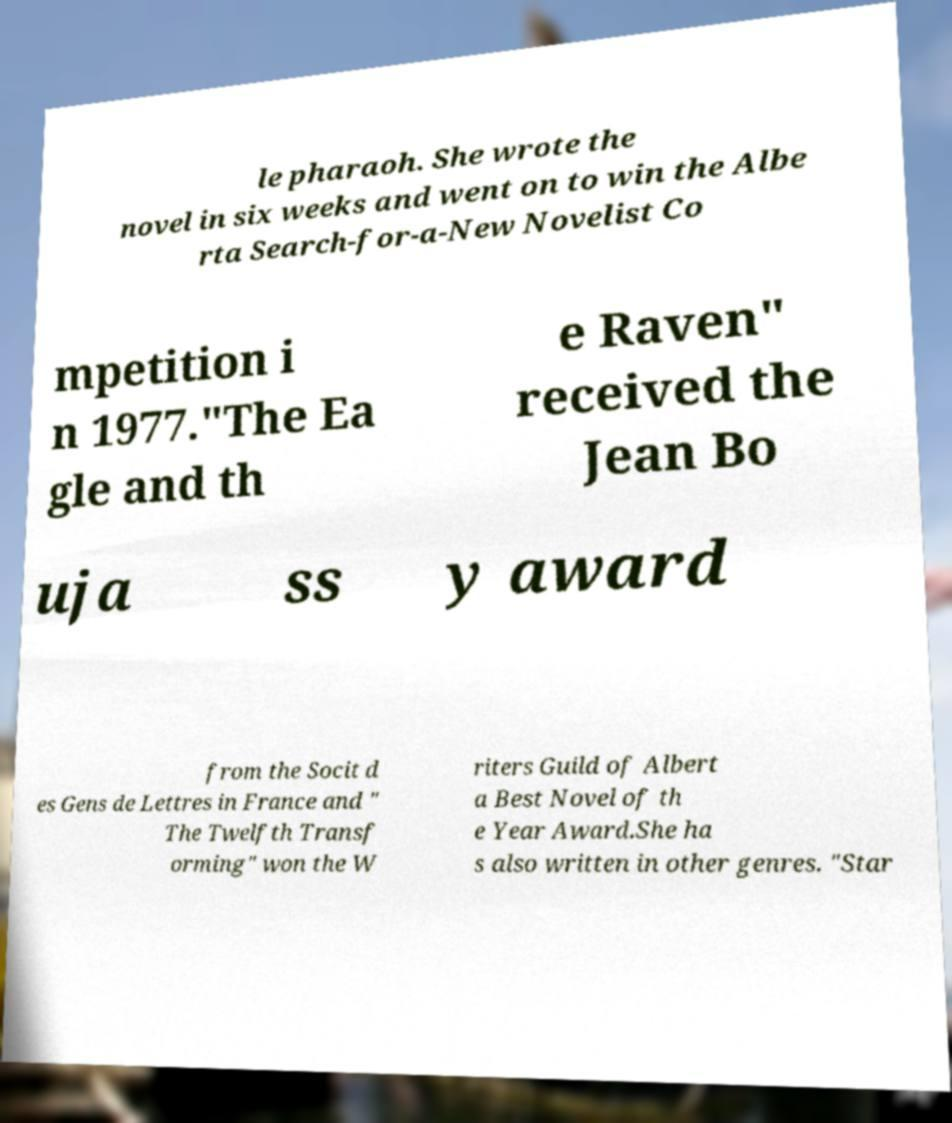Please read and relay the text visible in this image. What does it say? le pharaoh. She wrote the novel in six weeks and went on to win the Albe rta Search-for-a-New Novelist Co mpetition i n 1977."The Ea gle and th e Raven" received the Jean Bo uja ss y award from the Socit d es Gens de Lettres in France and " The Twelfth Transf orming" won the W riters Guild of Albert a Best Novel of th e Year Award.She ha s also written in other genres. "Star 